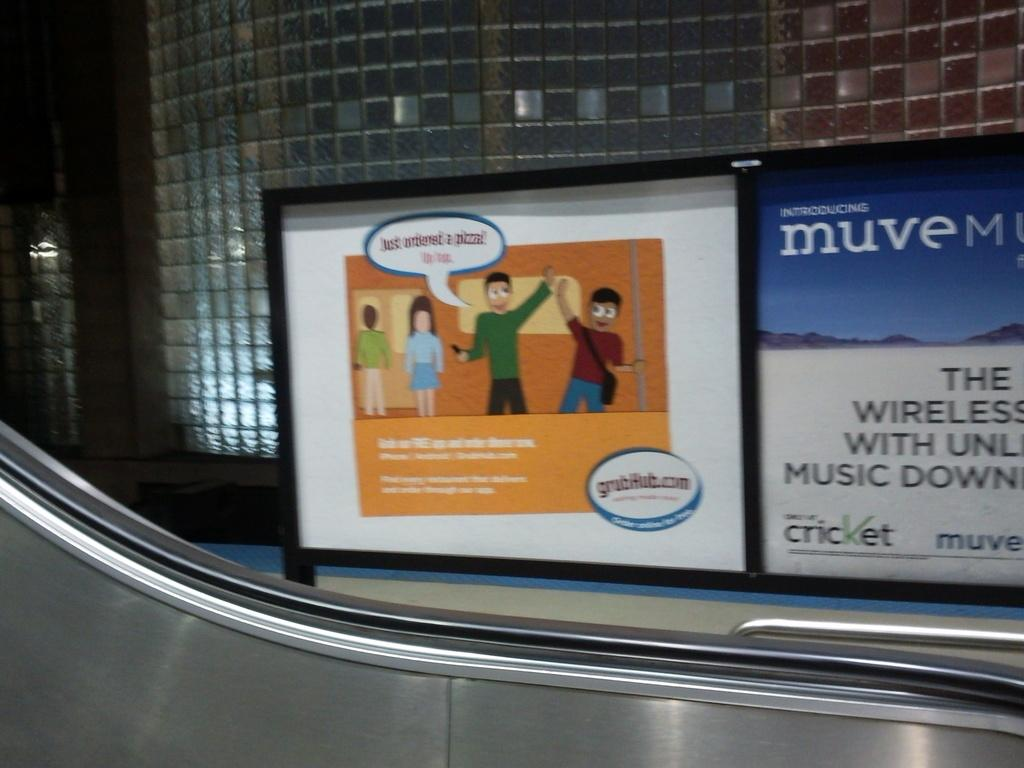What type of location is depicted in the image? The image shows an inner view of a building. What can be seen on the walls of the building? There is an advertisement board in the image. How can people move between floors in the building? There is an escalator in the image. What type of pleasure can be seen being enjoyed by the women in the image? There are no women or any indication of pleasure in the image; it shows an inner view of a building with an advertisement board and an escalator. 